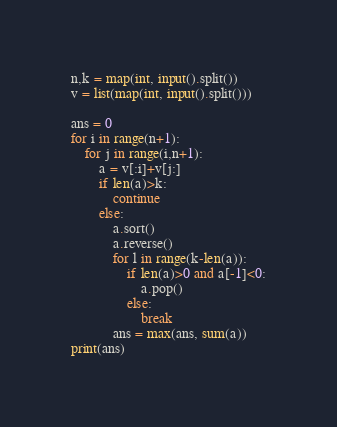<code> <loc_0><loc_0><loc_500><loc_500><_Python_>n,k = map(int, input().split())
v = list(map(int, input().split()))

ans = 0
for i in range(n+1):
    for j in range(i,n+1):
        a = v[:i]+v[j:]
        if len(a)>k:
            continue
        else:
            a.sort()
            a.reverse()
            for l in range(k-len(a)):
                if len(a)>0 and a[-1]<0:
                    a.pop()
                else:
                    break
            ans = max(ans, sum(a))
print(ans)


</code> 